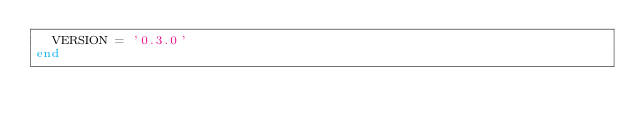Convert code to text. <code><loc_0><loc_0><loc_500><loc_500><_Ruby_>  VERSION = '0.3.0'
end</code> 